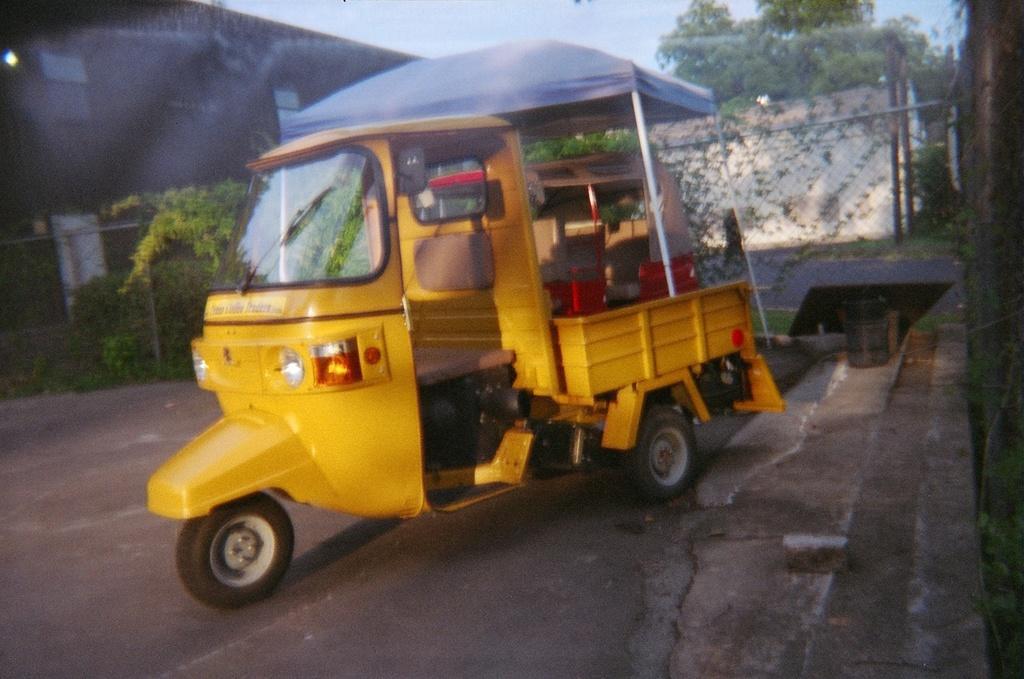Could you give a brief overview of what you see in this image? In the center of the image, we can see an auto on the road and in the background, there are buildings, trees and we can see a mesh. 